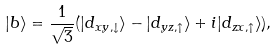Convert formula to latex. <formula><loc_0><loc_0><loc_500><loc_500>| b \rangle = \frac { 1 } { \sqrt { 3 } } ( | d _ { x y , \downarrow } \rangle - | d _ { y z , \uparrow } \rangle + i | d _ { z x , \uparrow } \rangle ) ,</formula> 